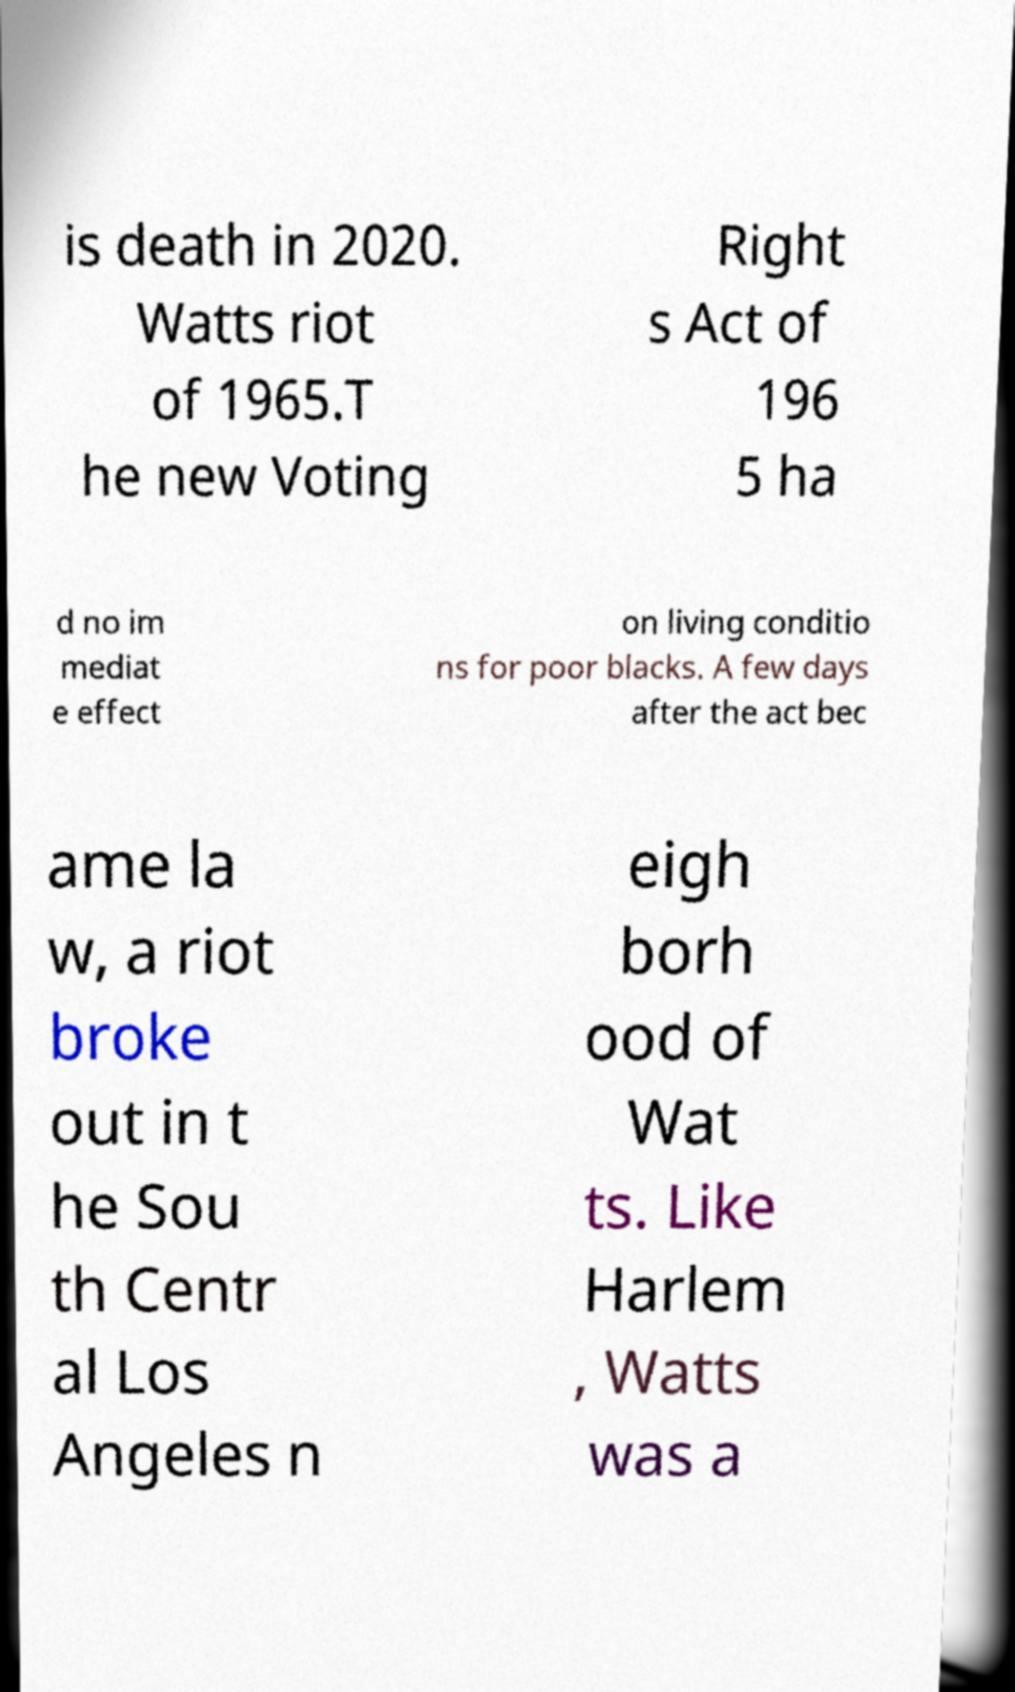What messages or text are displayed in this image? I need them in a readable, typed format. is death in 2020. Watts riot of 1965.T he new Voting Right s Act of 196 5 ha d no im mediat e effect on living conditio ns for poor blacks. A few days after the act bec ame la w, a riot broke out in t he Sou th Centr al Los Angeles n eigh borh ood of Wat ts. Like Harlem , Watts was a 